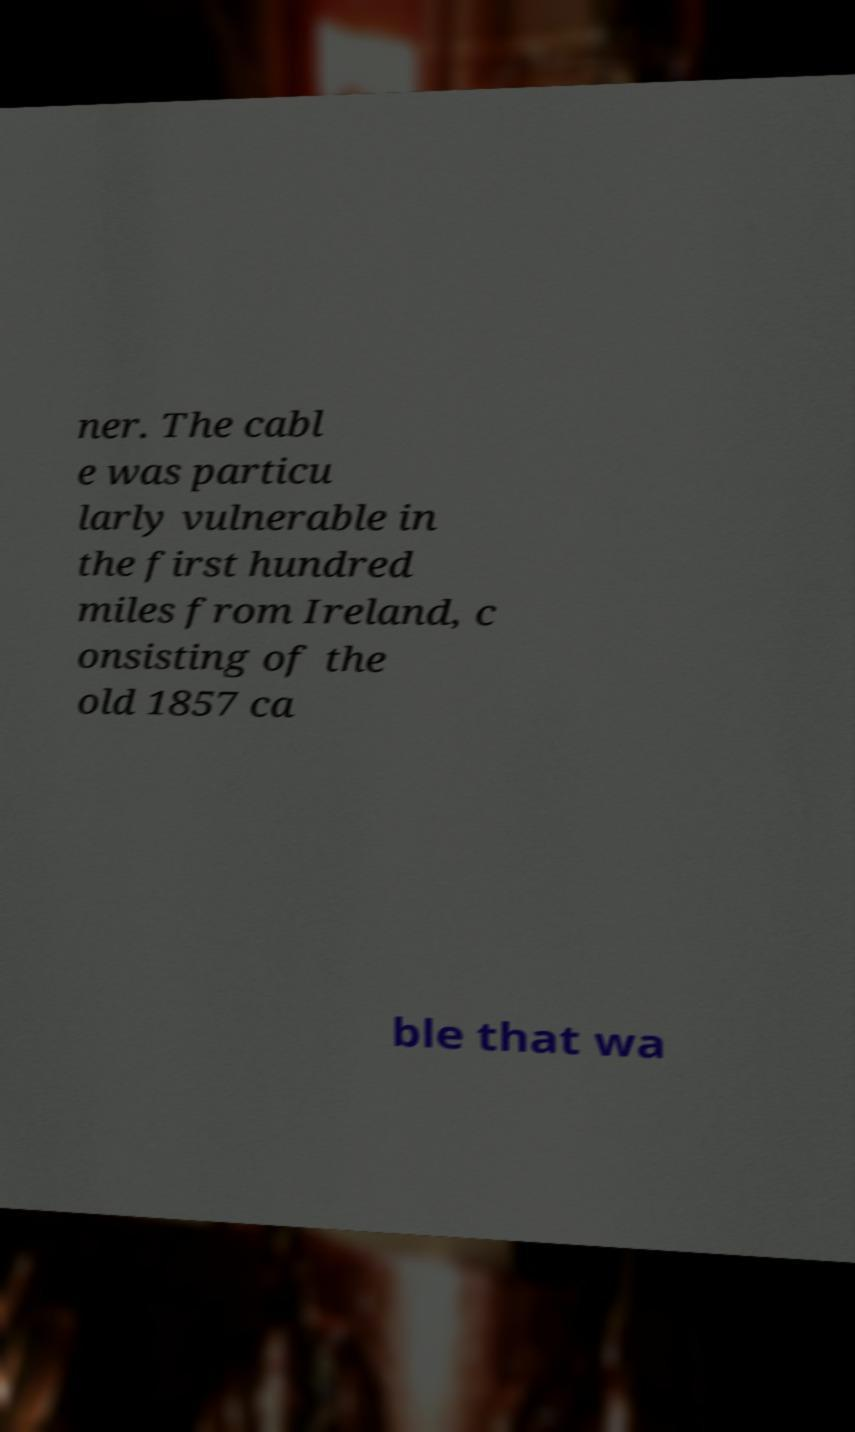Can you read and provide the text displayed in the image?This photo seems to have some interesting text. Can you extract and type it out for me? ner. The cabl e was particu larly vulnerable in the first hundred miles from Ireland, c onsisting of the old 1857 ca ble that wa 